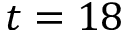<formula> <loc_0><loc_0><loc_500><loc_500>t = 1 8</formula> 